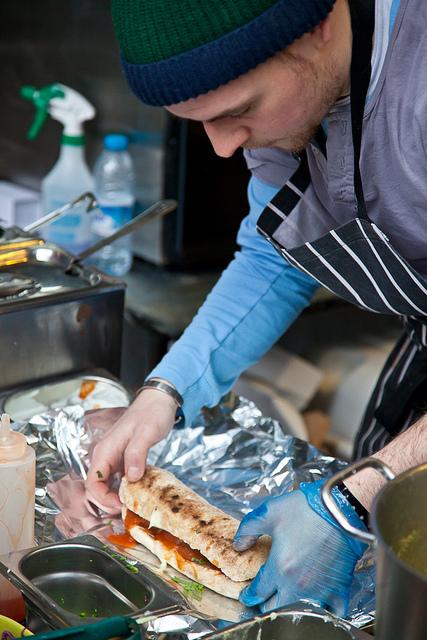What is the man preparing?
Short answer required. Sandwich. Does this look messy to eat?
Give a very brief answer. Yes. What is the man wearing on his head?
Answer briefly. Hat. 